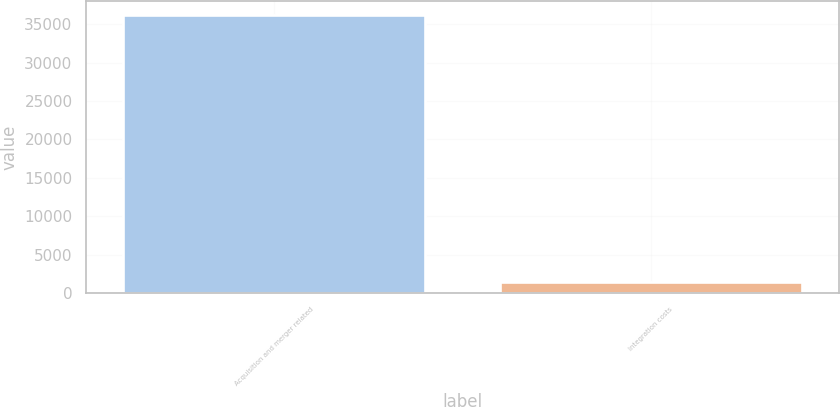Convert chart. <chart><loc_0><loc_0><loc_500><loc_500><bar_chart><fcel>Acquisition and merger related<fcel>Integration costs<nl><fcel>36172<fcel>1424<nl></chart> 